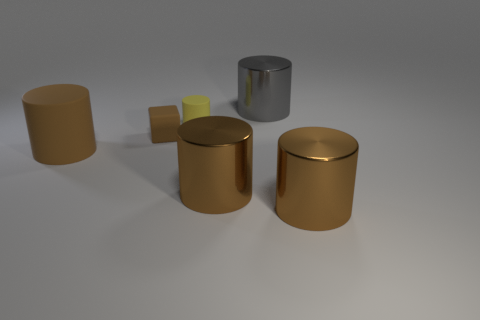The rubber cylinder that is the same size as the gray object is what color?
Your answer should be compact. Brown. Is the large gray cylinder made of the same material as the tiny yellow cylinder?
Your response must be concise. No. What number of small rubber cubes are the same color as the small matte cylinder?
Your response must be concise. 0. Do the matte cube and the big rubber thing have the same color?
Make the answer very short. Yes. What is the object that is behind the small rubber cylinder made of?
Give a very brief answer. Metal. What number of small things are brown metal things or yellow rubber balls?
Keep it short and to the point. 0. There is a block that is the same color as the large matte cylinder; what is its material?
Provide a succinct answer. Rubber. Are there any other cyan cubes that have the same material as the small block?
Your response must be concise. No. There is a rubber cylinder that is to the left of the brown rubber cube; does it have the same size as the large gray cylinder?
Your answer should be compact. Yes. There is a yellow rubber object that is behind the rubber cylinder that is on the left side of the small brown rubber object; is there a big gray metal thing that is on the left side of it?
Keep it short and to the point. No. 